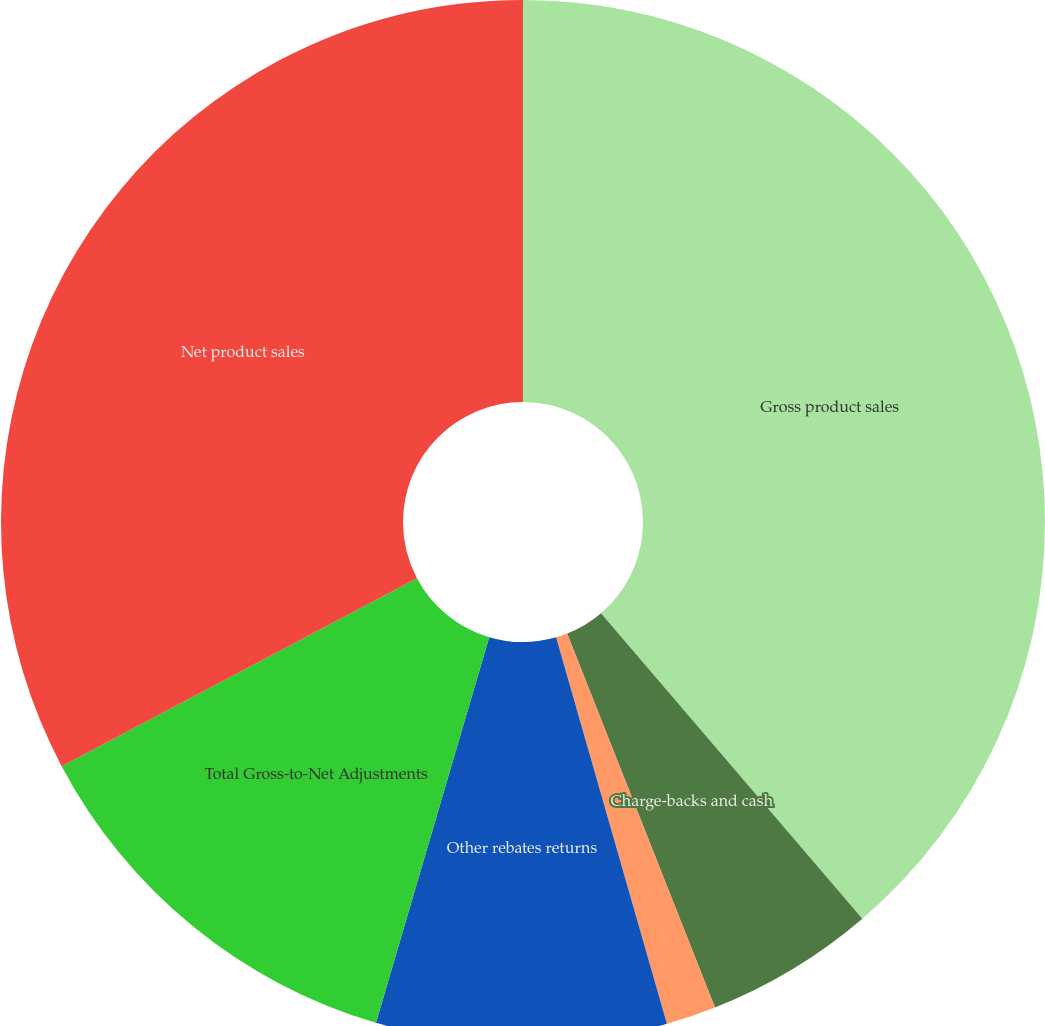<chart> <loc_0><loc_0><loc_500><loc_500><pie_chart><fcel>Gross product sales<fcel>Charge-backs and cash<fcel>Medicaid and Medicare rebates<fcel>Other rebates returns<fcel>Total Gross-to-Net Adjustments<fcel>Net product sales<nl><fcel>38.74%<fcel>5.27%<fcel>1.55%<fcel>8.99%<fcel>12.71%<fcel>32.75%<nl></chart> 